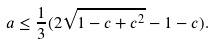Convert formula to latex. <formula><loc_0><loc_0><loc_500><loc_500>a \leq \frac { 1 } { 3 } ( 2 \sqrt { 1 - c + c ^ { 2 } } - 1 - c ) .</formula> 